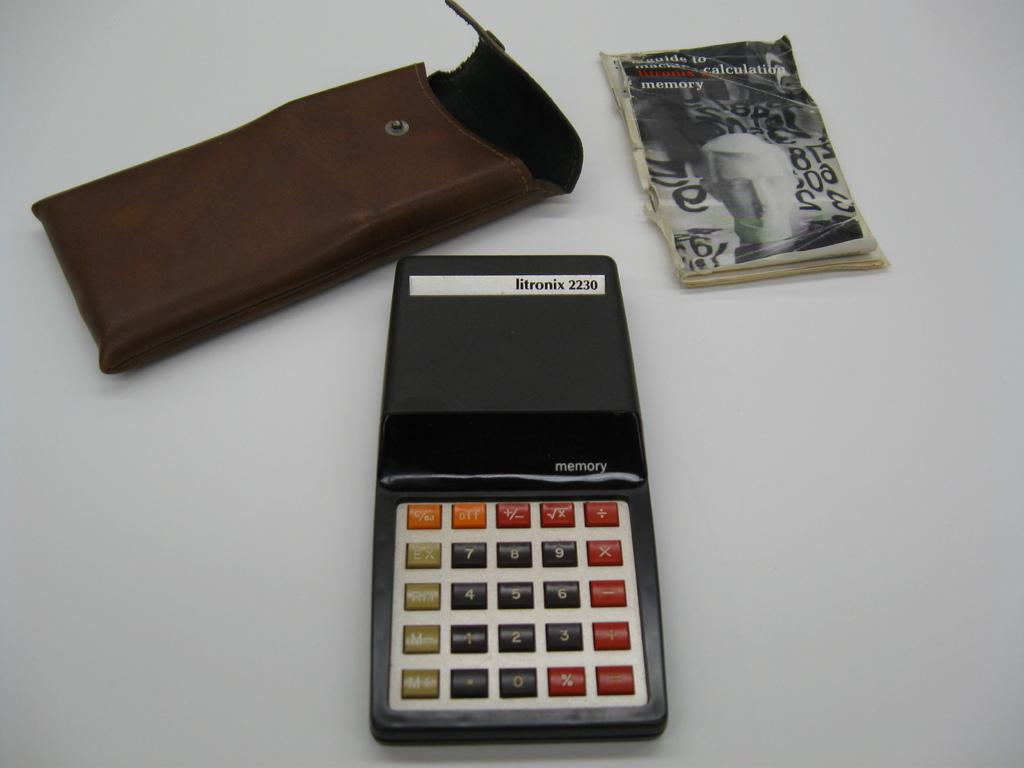<image>
Share a concise interpretation of the image provided. A litronix calculator with a case and manual. 